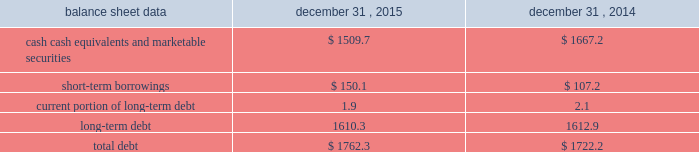Management 2019s discussion and analysis of financial condition and results of operations 2013 ( continued ) ( amounts in millions , except per share amounts ) financing activities net cash used in financing activities during 2015 primarily related to the repurchase of our common stock and payment of dividends .
We repurchased 13.6 shares of our common stock for an aggregate cost of $ 285.2 , including fees , and made dividend payments of $ 195.5 on our common stock .
Net cash used in financing activities during 2014 primarily related to the purchase of long-term debt , the repurchase of our common stock and payment of dividends .
We redeemed all $ 350.0 in aggregate principal amount of our 6.25% ( 6.25 % ) notes , repurchased 14.9 shares of our common stock for an aggregate cost of $ 275.1 , including fees , and made dividend payments of $ 159.0 on our common stock .
This was offset by the issuance of $ 500.0 in aggregate principal amount of our 4.20% ( 4.20 % ) notes .
Foreign exchange rate changes the effect of foreign exchange rate changes on cash and cash equivalents included in the consolidated statements of cash flows resulted in a decrease of $ 156.1 in 2015 .
The decrease was primarily a result of the u.s .
Dollar being stronger than several foreign currencies , including the australian dollar , brazilian real , canadian dollar , euro and south african rand as of december 31 , 2015 compared to december 31 , 2014 .
The effect of foreign exchange rate changes on cash and cash equivalents included in the consolidated statements of cash flows resulted in a decrease of $ 101.0 in 2014 .
The decrease was primarily a result of the u.s .
Dollar being stronger than several foreign currencies , including the australian dollar , brazilian real , canadian dollar and euro as of december 31 , 2014 compared to december 31 , 2013. .
Liquidity outlook we expect our cash flow from operations , cash and cash equivalents to be sufficient to meet our anticipated operating requirements at a minimum for the next twelve months .
We also have a committed corporate credit facility as well as uncommitted facilities available to support our operating needs .
We continue to maintain a disciplined approach to managing liquidity , with flexibility over significant uses of cash , including our capital expenditures , cash used for new acquisitions , our common stock repurchase program and our common stock dividends .
From time to time , we evaluate market conditions and financing alternatives for opportunities to raise additional funds or otherwise improve our liquidity profile , enhance our financial flexibility and manage market risk .
Our ability to access the capital markets depends on a number of factors , which include those specific to us , such as our credit rating , and those related to the financial markets , such as the amount or terms of available credit .
There can be no guarantee that we would be able to access new sources of liquidity on commercially reasonable terms , or at all .
Funding requirements our most significant funding requirements include our operations , non-cancelable operating lease obligations , capital expenditures , acquisitions , common stock dividends , taxes , debt service and contributions to pension and postretirement plans .
Additionally , we may be required to make payments to minority shareholders in certain subsidiaries if they exercise their options to sell us their equity interests. .
What was the average dividend payment per share of common stock that was repurchased , per quarter? 
Computations: ((195.5 / 13.6) / 4)
Answer: 3.59375. 